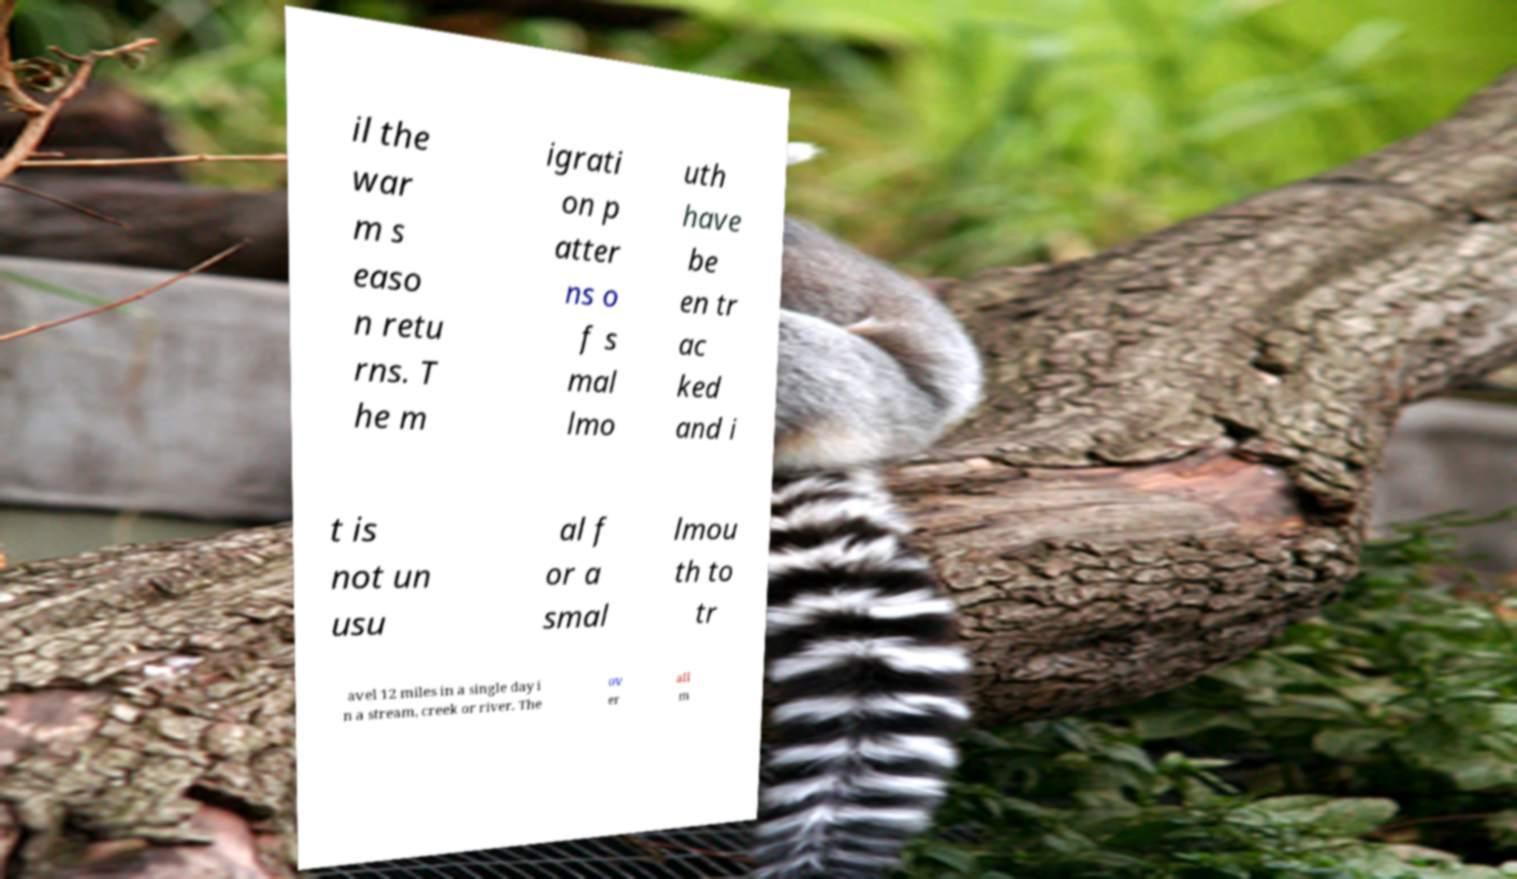Can you accurately transcribe the text from the provided image for me? il the war m s easo n retu rns. T he m igrati on p atter ns o f s mal lmo uth have be en tr ac ked and i t is not un usu al f or a smal lmou th to tr avel 12 miles in a single day i n a stream, creek or river. The ov er all m 